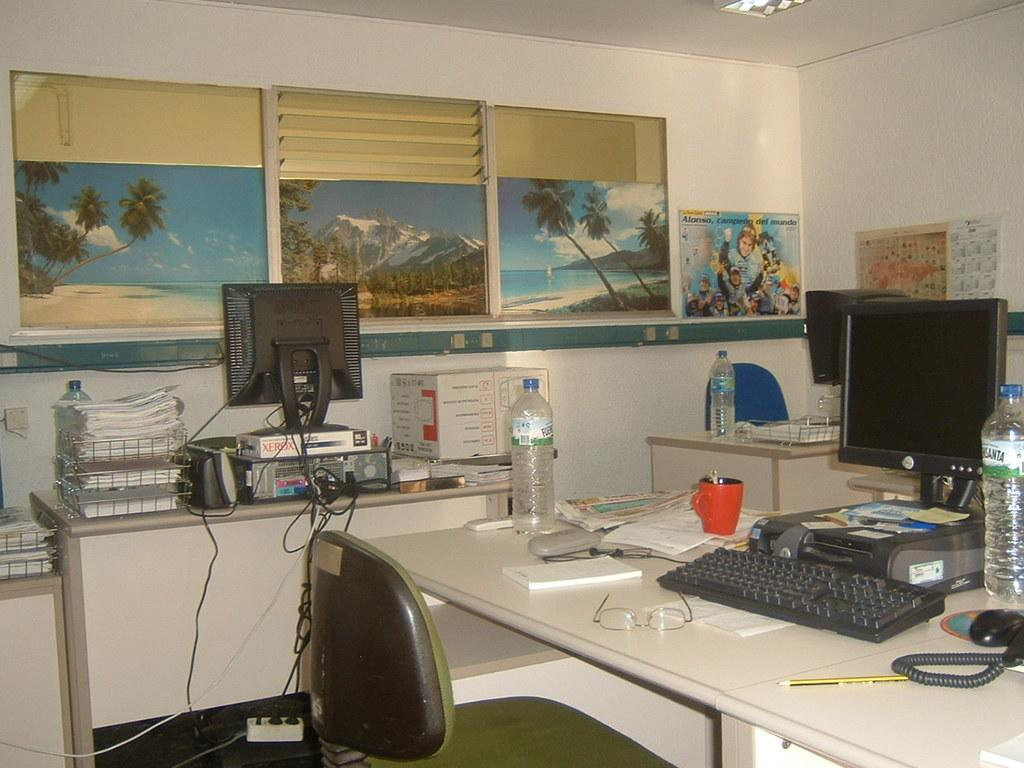<image>
Present a compact description of the photo's key features. A pack of Xerox paper sits under a monitor on a desk. 